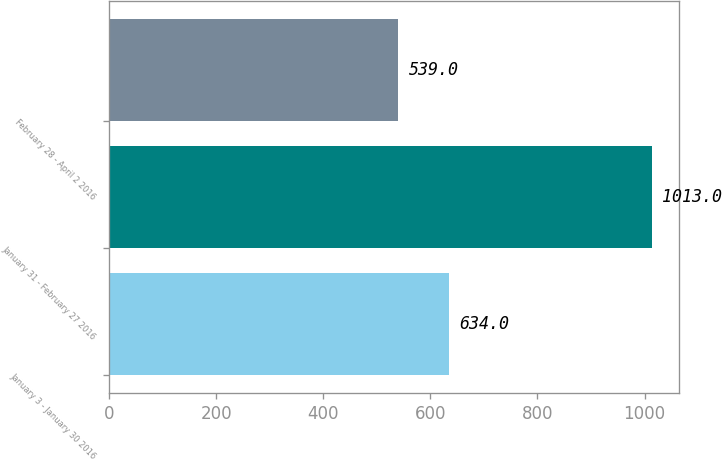<chart> <loc_0><loc_0><loc_500><loc_500><bar_chart><fcel>January 3 - January 30 2016<fcel>January 31 - February 27 2016<fcel>February 28 - April 2 2016<nl><fcel>634<fcel>1013<fcel>539<nl></chart> 